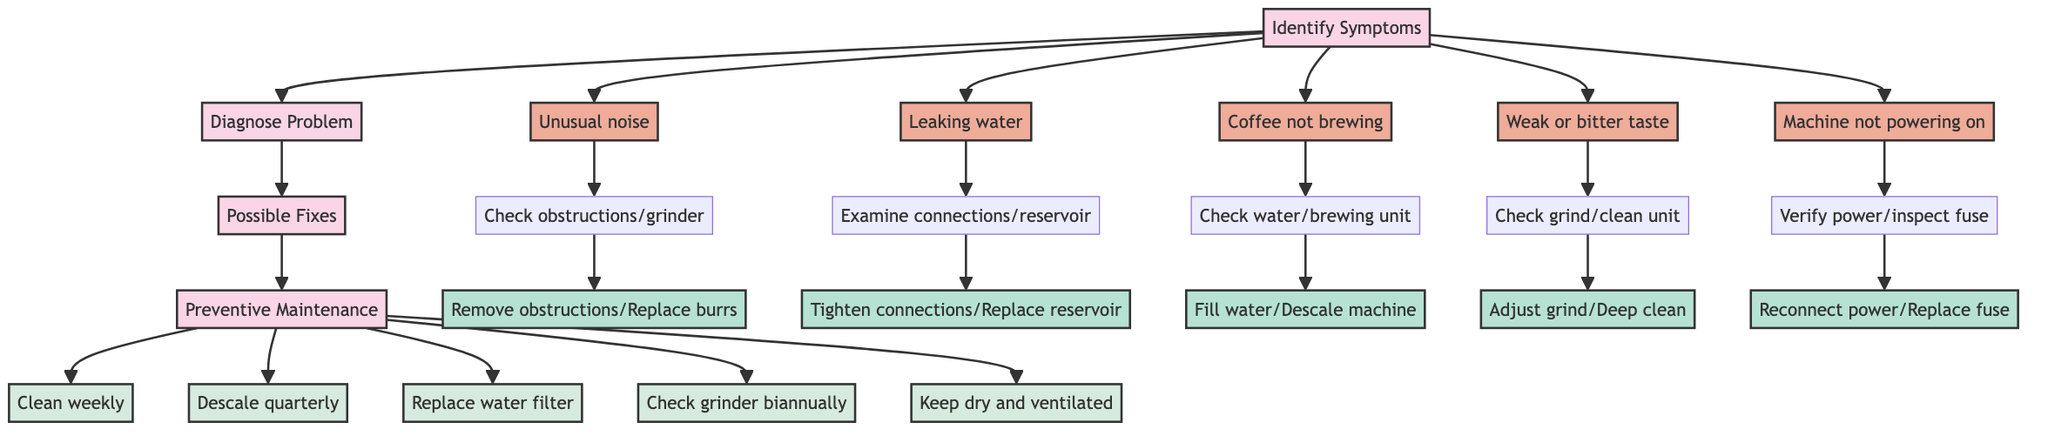What is the first step in the clinical pathway? The first step in the clinical pathway, as indicated in the diagram, is "Identify Symptoms." This is the initial node from which the rest of the process flows.
Answer: Identify Symptoms How many symptoms are listed in Step 1? Step 1 lists five symptoms: unusual noise, leaking water, coffee not brewing, weak or bitter taste, and machine not powering on. By counting them, we find there are five symptoms total.
Answer: 5 What is the relationship between "Diagnose Problem" and "Machine not powering on"? "Machine not powering on" is a symptom that leads directly to the "Diagnose Problem" step. It is part of the flow from identifying symptoms to diagnosing issues.
Answer: Direct relationship Which possible fix corresponds to the symptom "Leaking water"? The possible fixes for the symptom "Leaking water" include "Tighten hose connections" and "Replace water reservoir." These are the actions recommended based on the diagnosis of that issue.
Answer: Tighten hose connections, Replace water reservoir What preventive maintenance step is suggested for the machine biannually? The preventive maintenance step suggested for the machine biannually is "Check grinder." This is specified in the maintenance section of the diagram.
Answer: Check grinder How many possible fixes are listed for "Weak or bitter taste"? There are two possible fixes listed for "Weak or bitter taste": "Adjust grind size" and "Perform deep cleaning." Thus, the count for possible fixes in this case is two.
Answer: 2 What must be verified if the machine is not powering on? If the machine is not powering on, you must "Verify power connection" and "Inspect power switch and internal fuse." These are the checks to be performed during diagnosis.
Answer: Verify power connection, Inspect power switch and internal fuse What preventive maintenance should be performed every three months? The preventive maintenance that should be performed every three months is "Descale every 3 months." This is a scheduled maintenance activity indicated in the diagram.
Answer: Descale every 3 months Which step follows "Possible Fixes" in the clinical pathway? The step that follows "Possible Fixes" in the clinical pathway is "Preventive Maintenance." This shows the progression from diagnosing problems to preventative care.
Answer: Preventive Maintenance 